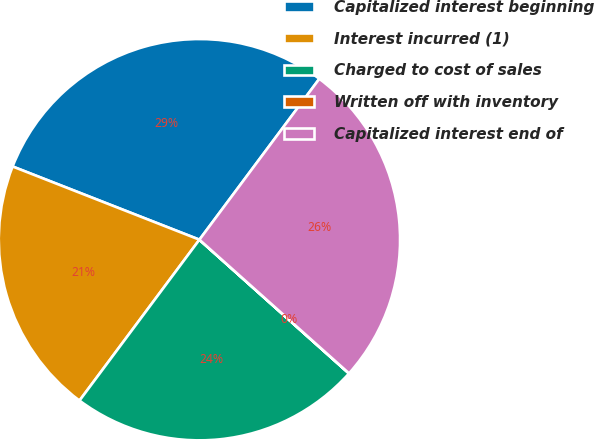Convert chart to OTSL. <chart><loc_0><loc_0><loc_500><loc_500><pie_chart><fcel>Capitalized interest beginning<fcel>Interest incurred (1)<fcel>Charged to cost of sales<fcel>Written off with inventory<fcel>Capitalized interest end of<nl><fcel>29.25%<fcel>20.75%<fcel>23.58%<fcel>0.01%<fcel>26.41%<nl></chart> 